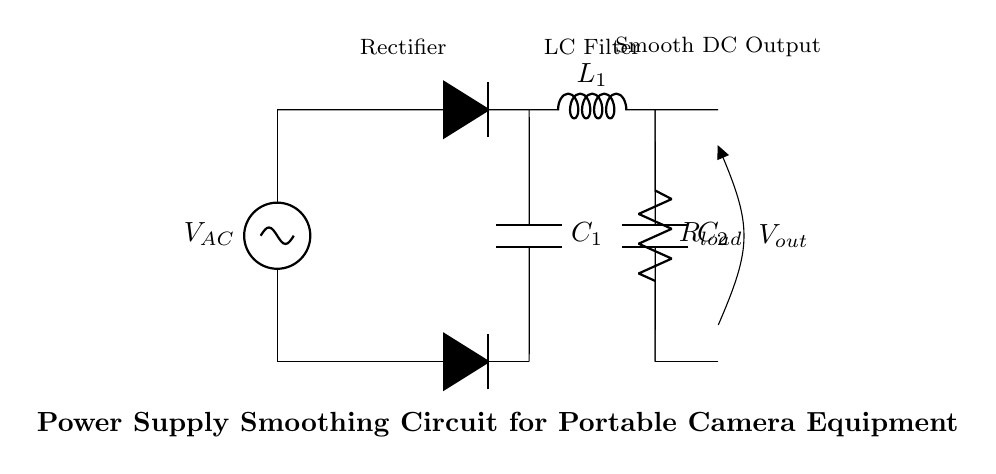What is the purpose of the capacitor in this circuit? The capacitor serves to smooth the rectified output voltage from fluctuations, helping to provide a more stable DC voltage for the load.
Answer: Smooth output What type of circuit is this? This is a power supply smoothing circuit specifically designed for filtering and stabilizing the voltage for portable camera equipment.
Answer: Smoothing circuit How many capacitors are in this circuit? There are two capacitors present in the circuit: C1 and C2.
Answer: Two What component is used to convert AC to DC? The diodes in the rectifier section are responsible for converting AC voltage to DC voltage.
Answer: Diodes What is the load component in this circuit? The load component is the resistor labeled as Rload, which represents the load being powered by the circuit.
Answer: Resistor Why is an inductor used along with capacitance in this filter? The inductor works in conjunction with the capacitor to create an LC filter that further reduces voltage ripple, enhancing the stability of the output voltage.
Answer: Reduce ripple 